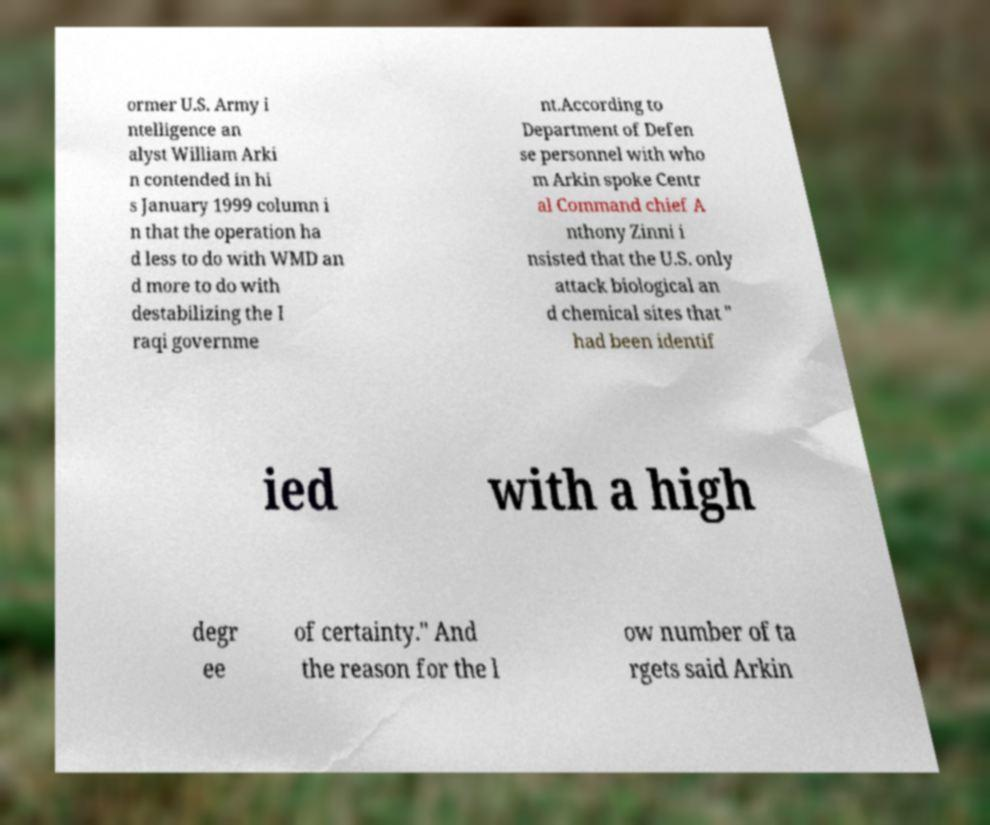Can you accurately transcribe the text from the provided image for me? ormer U.S. Army i ntelligence an alyst William Arki n contended in hi s January 1999 column i n that the operation ha d less to do with WMD an d more to do with destabilizing the I raqi governme nt.According to Department of Defen se personnel with who m Arkin spoke Centr al Command chief A nthony Zinni i nsisted that the U.S. only attack biological an d chemical sites that " had been identif ied with a high degr ee of certainty." And the reason for the l ow number of ta rgets said Arkin 